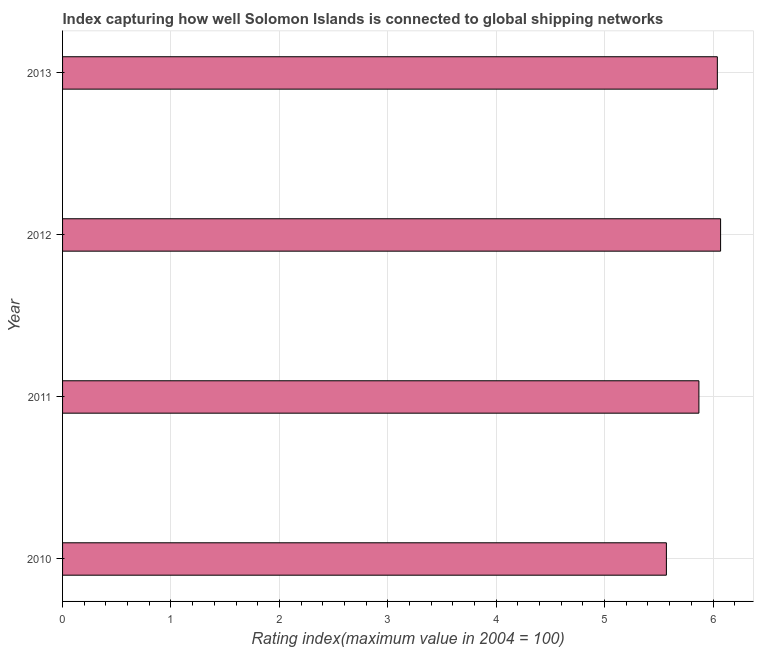Does the graph contain any zero values?
Offer a very short reply. No. What is the title of the graph?
Provide a succinct answer. Index capturing how well Solomon Islands is connected to global shipping networks. What is the label or title of the X-axis?
Make the answer very short. Rating index(maximum value in 2004 = 100). What is the label or title of the Y-axis?
Your answer should be very brief. Year. What is the liner shipping connectivity index in 2013?
Make the answer very short. 6.04. Across all years, what is the maximum liner shipping connectivity index?
Ensure brevity in your answer.  6.07. Across all years, what is the minimum liner shipping connectivity index?
Offer a very short reply. 5.57. In which year was the liner shipping connectivity index minimum?
Provide a short and direct response. 2010. What is the sum of the liner shipping connectivity index?
Make the answer very short. 23.55. What is the average liner shipping connectivity index per year?
Offer a very short reply. 5.89. What is the median liner shipping connectivity index?
Offer a very short reply. 5.96. In how many years, is the liner shipping connectivity index greater than 1.8 ?
Ensure brevity in your answer.  4. What is the ratio of the liner shipping connectivity index in 2012 to that in 2013?
Your response must be concise. 1. Is the difference between the liner shipping connectivity index in 2010 and 2011 greater than the difference between any two years?
Make the answer very short. No. What is the difference between the highest and the second highest liner shipping connectivity index?
Your answer should be compact. 0.03. Are all the bars in the graph horizontal?
Your response must be concise. Yes. How many years are there in the graph?
Your answer should be compact. 4. What is the difference between two consecutive major ticks on the X-axis?
Ensure brevity in your answer.  1. What is the Rating index(maximum value in 2004 = 100) of 2010?
Keep it short and to the point. 5.57. What is the Rating index(maximum value in 2004 = 100) of 2011?
Offer a terse response. 5.87. What is the Rating index(maximum value in 2004 = 100) in 2012?
Your response must be concise. 6.07. What is the Rating index(maximum value in 2004 = 100) in 2013?
Provide a succinct answer. 6.04. What is the difference between the Rating index(maximum value in 2004 = 100) in 2010 and 2012?
Keep it short and to the point. -0.5. What is the difference between the Rating index(maximum value in 2004 = 100) in 2010 and 2013?
Offer a terse response. -0.47. What is the difference between the Rating index(maximum value in 2004 = 100) in 2011 and 2013?
Make the answer very short. -0.17. What is the difference between the Rating index(maximum value in 2004 = 100) in 2012 and 2013?
Ensure brevity in your answer.  0.03. What is the ratio of the Rating index(maximum value in 2004 = 100) in 2010 to that in 2011?
Give a very brief answer. 0.95. What is the ratio of the Rating index(maximum value in 2004 = 100) in 2010 to that in 2012?
Ensure brevity in your answer.  0.92. What is the ratio of the Rating index(maximum value in 2004 = 100) in 2010 to that in 2013?
Provide a succinct answer. 0.92. What is the ratio of the Rating index(maximum value in 2004 = 100) in 2011 to that in 2013?
Your answer should be compact. 0.97. What is the ratio of the Rating index(maximum value in 2004 = 100) in 2012 to that in 2013?
Give a very brief answer. 1. 